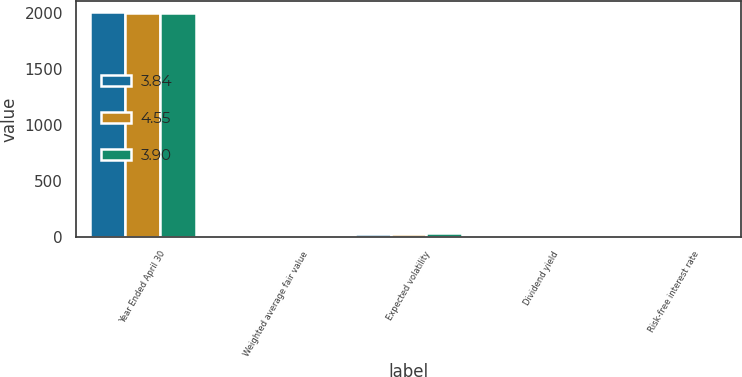Convert chart. <chart><loc_0><loc_0><loc_500><loc_500><stacked_bar_chart><ecel><fcel>Year Ended April 30<fcel>Weighted average fair value<fcel>Expected volatility<fcel>Dividend yield<fcel>Risk-free interest rate<nl><fcel>3.84<fcel>2007<fcel>5.15<fcel>20.05<fcel>2.26<fcel>5.11<nl><fcel>4.55<fcel>2006<fcel>7.37<fcel>23.28<fcel>1.71<fcel>3.61<nl><fcel>3.9<fcel>2005<fcel>6.9<fcel>27.65<fcel>1.85<fcel>2.6<nl></chart> 